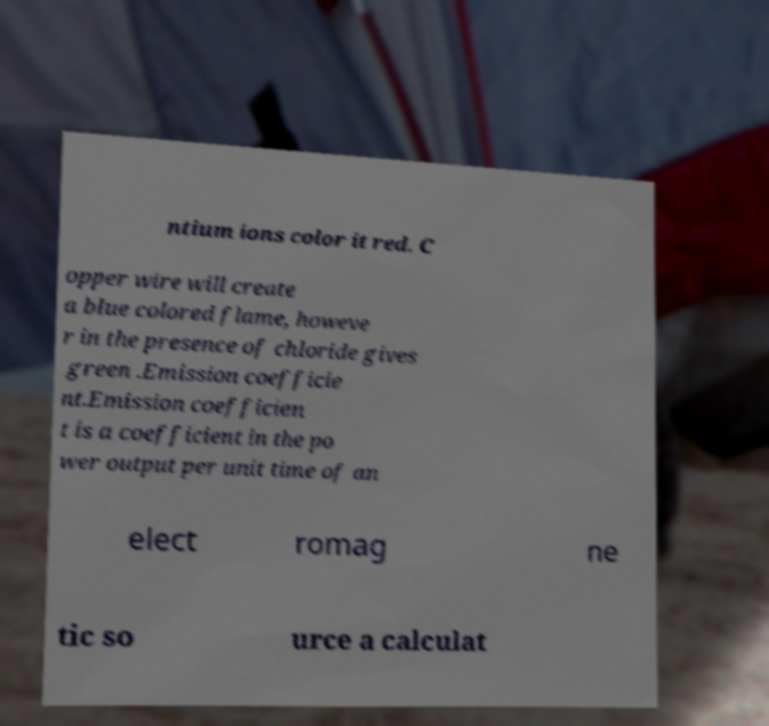There's text embedded in this image that I need extracted. Can you transcribe it verbatim? ntium ions color it red. C opper wire will create a blue colored flame, howeve r in the presence of chloride gives green .Emission coefficie nt.Emission coefficien t is a coefficient in the po wer output per unit time of an elect romag ne tic so urce a calculat 